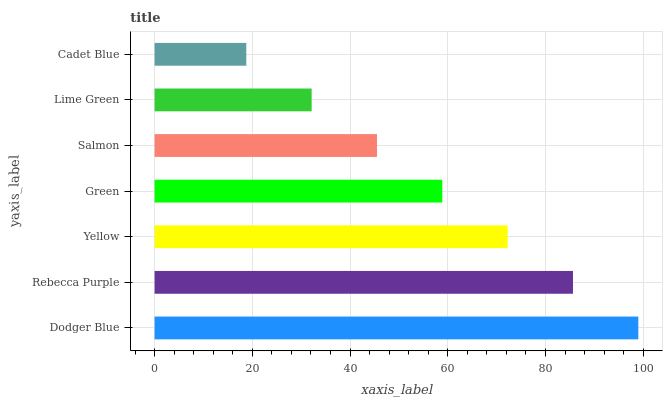Is Cadet Blue the minimum?
Answer yes or no. Yes. Is Dodger Blue the maximum?
Answer yes or no. Yes. Is Rebecca Purple the minimum?
Answer yes or no. No. Is Rebecca Purple the maximum?
Answer yes or no. No. Is Dodger Blue greater than Rebecca Purple?
Answer yes or no. Yes. Is Rebecca Purple less than Dodger Blue?
Answer yes or no. Yes. Is Rebecca Purple greater than Dodger Blue?
Answer yes or no. No. Is Dodger Blue less than Rebecca Purple?
Answer yes or no. No. Is Green the high median?
Answer yes or no. Yes. Is Green the low median?
Answer yes or no. Yes. Is Salmon the high median?
Answer yes or no. No. Is Yellow the low median?
Answer yes or no. No. 